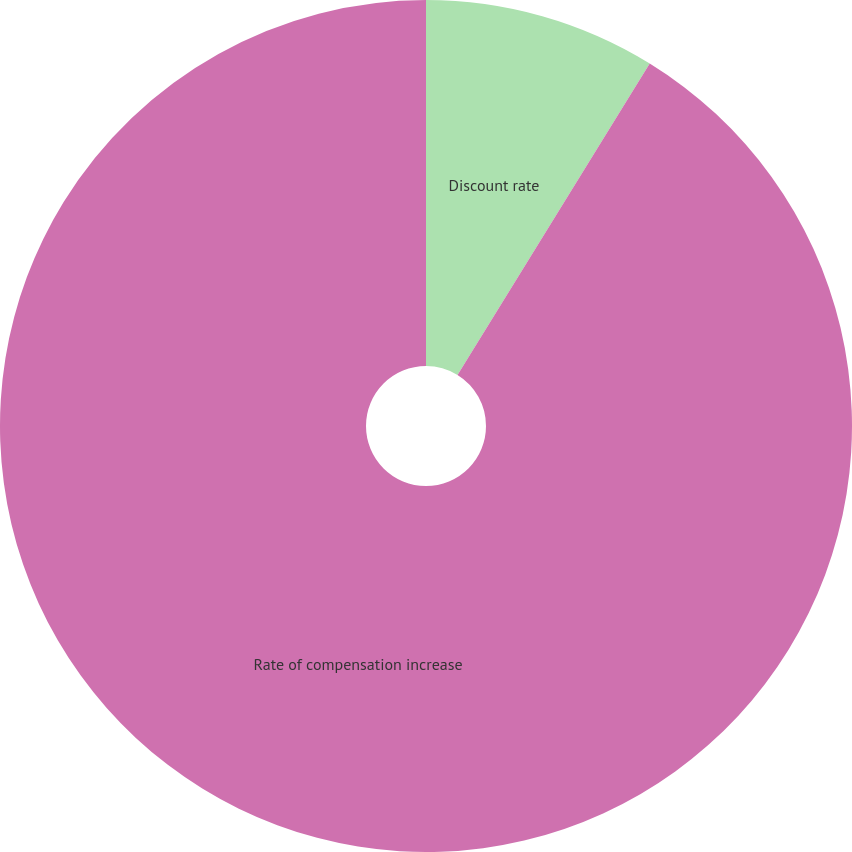Convert chart. <chart><loc_0><loc_0><loc_500><loc_500><pie_chart><fcel>Discount rate<fcel>Rate of compensation increase<nl><fcel>8.8%<fcel>91.2%<nl></chart> 